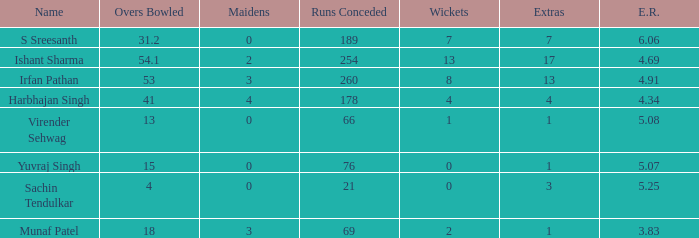Could you help me parse every detail presented in this table? {'header': ['Name', 'Overs Bowled', 'Maidens', 'Runs Conceded', 'Wickets', 'Extras', 'E.R.'], 'rows': [['S Sreesanth', '31.2', '0', '189', '7', '7', '6.06'], ['Ishant Sharma', '54.1', '2', '254', '13', '17', '4.69'], ['Irfan Pathan', '53', '3', '260', '8', '13', '4.91'], ['Harbhajan Singh', '41', '4', '178', '4', '4', '4.34'], ['Virender Sehwag', '13', '0', '66', '1', '1', '5.08'], ['Yuvraj Singh', '15', '0', '76', '0', '1', '5.07'], ['Sachin Tendulkar', '4', '0', '21', '0', '3', '5.25'], ['Munaf Patel', '18', '3', '69', '2', '1', '3.83']]} Specify the aggregate amount of wickets for yuvraj singh. 1.0. 